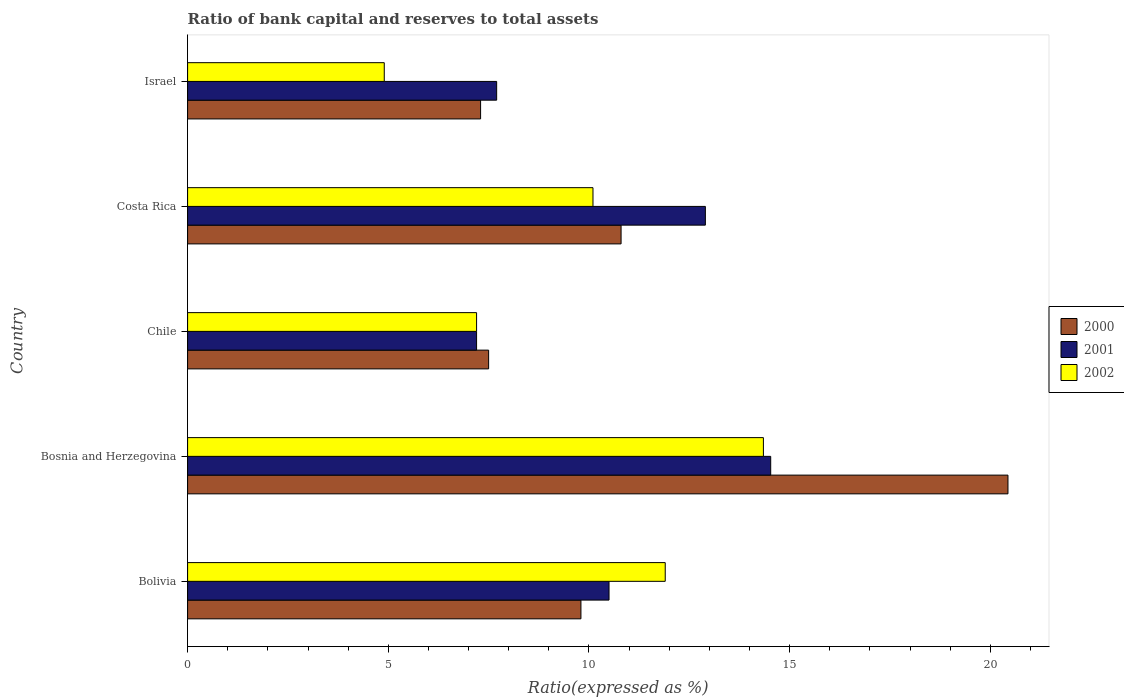How many different coloured bars are there?
Provide a short and direct response. 3. How many groups of bars are there?
Provide a succinct answer. 5. What is the label of the 5th group of bars from the top?
Provide a short and direct response. Bolivia. In how many cases, is the number of bars for a given country not equal to the number of legend labels?
Provide a short and direct response. 0. Across all countries, what is the maximum ratio of bank capital and reserves to total assets in 2000?
Keep it short and to the point. 20.44. Across all countries, what is the minimum ratio of bank capital and reserves to total assets in 2000?
Provide a succinct answer. 7.3. In which country was the ratio of bank capital and reserves to total assets in 2000 maximum?
Keep it short and to the point. Bosnia and Herzegovina. In which country was the ratio of bank capital and reserves to total assets in 2000 minimum?
Your answer should be very brief. Israel. What is the total ratio of bank capital and reserves to total assets in 2001 in the graph?
Your answer should be compact. 52.83. What is the difference between the ratio of bank capital and reserves to total assets in 2001 in Chile and that in Israel?
Give a very brief answer. -0.5. What is the average ratio of bank capital and reserves to total assets in 2001 per country?
Offer a very short reply. 10.57. What is the difference between the ratio of bank capital and reserves to total assets in 2000 and ratio of bank capital and reserves to total assets in 2001 in Israel?
Provide a short and direct response. -0.4. What is the ratio of the ratio of bank capital and reserves to total assets in 2000 in Bosnia and Herzegovina to that in Costa Rica?
Provide a succinct answer. 1.89. Is the ratio of bank capital and reserves to total assets in 2002 in Chile less than that in Costa Rica?
Ensure brevity in your answer.  Yes. What is the difference between the highest and the second highest ratio of bank capital and reserves to total assets in 2001?
Your answer should be very brief. 1.63. What is the difference between the highest and the lowest ratio of bank capital and reserves to total assets in 2002?
Your answer should be compact. 9.45. Is the sum of the ratio of bank capital and reserves to total assets in 2000 in Bosnia and Herzegovina and Chile greater than the maximum ratio of bank capital and reserves to total assets in 2001 across all countries?
Your answer should be compact. Yes. What does the 1st bar from the top in Israel represents?
Your response must be concise. 2002. What does the 3rd bar from the bottom in Israel represents?
Your response must be concise. 2002. How many bars are there?
Ensure brevity in your answer.  15. Are all the bars in the graph horizontal?
Give a very brief answer. Yes. How many countries are there in the graph?
Keep it short and to the point. 5. What is the difference between two consecutive major ticks on the X-axis?
Your answer should be very brief. 5. Are the values on the major ticks of X-axis written in scientific E-notation?
Your response must be concise. No. What is the title of the graph?
Make the answer very short. Ratio of bank capital and reserves to total assets. What is the label or title of the X-axis?
Your answer should be compact. Ratio(expressed as %). What is the label or title of the Y-axis?
Provide a short and direct response. Country. What is the Ratio(expressed as %) of 2000 in Bolivia?
Give a very brief answer. 9.8. What is the Ratio(expressed as %) in 2000 in Bosnia and Herzegovina?
Provide a short and direct response. 20.44. What is the Ratio(expressed as %) in 2001 in Bosnia and Herzegovina?
Keep it short and to the point. 14.53. What is the Ratio(expressed as %) of 2002 in Bosnia and Herzegovina?
Keep it short and to the point. 14.35. What is the Ratio(expressed as %) of 2001 in Chile?
Ensure brevity in your answer.  7.2. What is the Ratio(expressed as %) in 2002 in Chile?
Ensure brevity in your answer.  7.2. What is the Ratio(expressed as %) in 2000 in Costa Rica?
Your response must be concise. 10.8. What is the Ratio(expressed as %) in 2002 in Costa Rica?
Make the answer very short. 10.1. What is the Ratio(expressed as %) in 2002 in Israel?
Ensure brevity in your answer.  4.9. Across all countries, what is the maximum Ratio(expressed as %) in 2000?
Your answer should be compact. 20.44. Across all countries, what is the maximum Ratio(expressed as %) in 2001?
Your response must be concise. 14.53. Across all countries, what is the maximum Ratio(expressed as %) of 2002?
Give a very brief answer. 14.35. Across all countries, what is the minimum Ratio(expressed as %) in 2001?
Provide a short and direct response. 7.2. Across all countries, what is the minimum Ratio(expressed as %) of 2002?
Your answer should be very brief. 4.9. What is the total Ratio(expressed as %) of 2000 in the graph?
Keep it short and to the point. 55.84. What is the total Ratio(expressed as %) in 2001 in the graph?
Your response must be concise. 52.83. What is the total Ratio(expressed as %) of 2002 in the graph?
Offer a terse response. 48.45. What is the difference between the Ratio(expressed as %) in 2000 in Bolivia and that in Bosnia and Herzegovina?
Give a very brief answer. -10.64. What is the difference between the Ratio(expressed as %) of 2001 in Bolivia and that in Bosnia and Herzegovina?
Make the answer very short. -4.03. What is the difference between the Ratio(expressed as %) in 2002 in Bolivia and that in Bosnia and Herzegovina?
Your response must be concise. -2.45. What is the difference between the Ratio(expressed as %) of 2000 in Bolivia and that in Costa Rica?
Provide a short and direct response. -1. What is the difference between the Ratio(expressed as %) of 2002 in Bolivia and that in Israel?
Your answer should be compact. 7. What is the difference between the Ratio(expressed as %) in 2000 in Bosnia and Herzegovina and that in Chile?
Make the answer very short. 12.94. What is the difference between the Ratio(expressed as %) in 2001 in Bosnia and Herzegovina and that in Chile?
Ensure brevity in your answer.  7.33. What is the difference between the Ratio(expressed as %) of 2002 in Bosnia and Herzegovina and that in Chile?
Provide a succinct answer. 7.15. What is the difference between the Ratio(expressed as %) in 2000 in Bosnia and Herzegovina and that in Costa Rica?
Keep it short and to the point. 9.64. What is the difference between the Ratio(expressed as %) of 2001 in Bosnia and Herzegovina and that in Costa Rica?
Give a very brief answer. 1.63. What is the difference between the Ratio(expressed as %) in 2002 in Bosnia and Herzegovina and that in Costa Rica?
Offer a very short reply. 4.25. What is the difference between the Ratio(expressed as %) in 2000 in Bosnia and Herzegovina and that in Israel?
Offer a terse response. 13.14. What is the difference between the Ratio(expressed as %) of 2001 in Bosnia and Herzegovina and that in Israel?
Give a very brief answer. 6.83. What is the difference between the Ratio(expressed as %) in 2002 in Bosnia and Herzegovina and that in Israel?
Make the answer very short. 9.45. What is the difference between the Ratio(expressed as %) in 2001 in Chile and that in Costa Rica?
Your answer should be compact. -5.7. What is the difference between the Ratio(expressed as %) in 2001 in Chile and that in Israel?
Keep it short and to the point. -0.5. What is the difference between the Ratio(expressed as %) in 2002 in Chile and that in Israel?
Provide a succinct answer. 2.3. What is the difference between the Ratio(expressed as %) in 2000 in Costa Rica and that in Israel?
Your answer should be very brief. 3.5. What is the difference between the Ratio(expressed as %) of 2001 in Costa Rica and that in Israel?
Give a very brief answer. 5.2. What is the difference between the Ratio(expressed as %) in 2002 in Costa Rica and that in Israel?
Make the answer very short. 5.2. What is the difference between the Ratio(expressed as %) in 2000 in Bolivia and the Ratio(expressed as %) in 2001 in Bosnia and Herzegovina?
Offer a very short reply. -4.73. What is the difference between the Ratio(expressed as %) in 2000 in Bolivia and the Ratio(expressed as %) in 2002 in Bosnia and Herzegovina?
Make the answer very short. -4.55. What is the difference between the Ratio(expressed as %) of 2001 in Bolivia and the Ratio(expressed as %) of 2002 in Bosnia and Herzegovina?
Your response must be concise. -3.85. What is the difference between the Ratio(expressed as %) in 2000 in Bolivia and the Ratio(expressed as %) in 2001 in Chile?
Offer a very short reply. 2.6. What is the difference between the Ratio(expressed as %) in 2000 in Bolivia and the Ratio(expressed as %) in 2001 in Costa Rica?
Your response must be concise. -3.1. What is the difference between the Ratio(expressed as %) of 2000 in Bolivia and the Ratio(expressed as %) of 2002 in Costa Rica?
Your response must be concise. -0.3. What is the difference between the Ratio(expressed as %) in 2001 in Bolivia and the Ratio(expressed as %) in 2002 in Costa Rica?
Give a very brief answer. 0.4. What is the difference between the Ratio(expressed as %) of 2000 in Bolivia and the Ratio(expressed as %) of 2001 in Israel?
Your response must be concise. 2.1. What is the difference between the Ratio(expressed as %) in 2001 in Bolivia and the Ratio(expressed as %) in 2002 in Israel?
Give a very brief answer. 5.6. What is the difference between the Ratio(expressed as %) in 2000 in Bosnia and Herzegovina and the Ratio(expressed as %) in 2001 in Chile?
Offer a very short reply. 13.24. What is the difference between the Ratio(expressed as %) in 2000 in Bosnia and Herzegovina and the Ratio(expressed as %) in 2002 in Chile?
Provide a short and direct response. 13.24. What is the difference between the Ratio(expressed as %) in 2001 in Bosnia and Herzegovina and the Ratio(expressed as %) in 2002 in Chile?
Your response must be concise. 7.33. What is the difference between the Ratio(expressed as %) of 2000 in Bosnia and Herzegovina and the Ratio(expressed as %) of 2001 in Costa Rica?
Keep it short and to the point. 7.54. What is the difference between the Ratio(expressed as %) in 2000 in Bosnia and Herzegovina and the Ratio(expressed as %) in 2002 in Costa Rica?
Offer a terse response. 10.34. What is the difference between the Ratio(expressed as %) in 2001 in Bosnia and Herzegovina and the Ratio(expressed as %) in 2002 in Costa Rica?
Make the answer very short. 4.43. What is the difference between the Ratio(expressed as %) of 2000 in Bosnia and Herzegovina and the Ratio(expressed as %) of 2001 in Israel?
Give a very brief answer. 12.74. What is the difference between the Ratio(expressed as %) in 2000 in Bosnia and Herzegovina and the Ratio(expressed as %) in 2002 in Israel?
Give a very brief answer. 15.54. What is the difference between the Ratio(expressed as %) of 2001 in Bosnia and Herzegovina and the Ratio(expressed as %) of 2002 in Israel?
Your answer should be compact. 9.63. What is the difference between the Ratio(expressed as %) of 2001 in Chile and the Ratio(expressed as %) of 2002 in Israel?
Ensure brevity in your answer.  2.3. What is the difference between the Ratio(expressed as %) in 2000 in Costa Rica and the Ratio(expressed as %) in 2002 in Israel?
Make the answer very short. 5.9. What is the difference between the Ratio(expressed as %) of 2001 in Costa Rica and the Ratio(expressed as %) of 2002 in Israel?
Provide a succinct answer. 8. What is the average Ratio(expressed as %) of 2000 per country?
Offer a very short reply. 11.17. What is the average Ratio(expressed as %) of 2001 per country?
Your response must be concise. 10.57. What is the average Ratio(expressed as %) of 2002 per country?
Offer a terse response. 9.69. What is the difference between the Ratio(expressed as %) in 2000 and Ratio(expressed as %) in 2001 in Bolivia?
Make the answer very short. -0.7. What is the difference between the Ratio(expressed as %) of 2000 and Ratio(expressed as %) of 2002 in Bolivia?
Your answer should be very brief. -2.1. What is the difference between the Ratio(expressed as %) of 2000 and Ratio(expressed as %) of 2001 in Bosnia and Herzegovina?
Your answer should be very brief. 5.91. What is the difference between the Ratio(expressed as %) in 2000 and Ratio(expressed as %) in 2002 in Bosnia and Herzegovina?
Ensure brevity in your answer.  6.09. What is the difference between the Ratio(expressed as %) of 2001 and Ratio(expressed as %) of 2002 in Bosnia and Herzegovina?
Ensure brevity in your answer.  0.18. What is the difference between the Ratio(expressed as %) of 2001 and Ratio(expressed as %) of 2002 in Chile?
Keep it short and to the point. 0. What is the difference between the Ratio(expressed as %) of 2000 and Ratio(expressed as %) of 2001 in Costa Rica?
Keep it short and to the point. -2.1. What is the difference between the Ratio(expressed as %) of 2000 and Ratio(expressed as %) of 2002 in Costa Rica?
Your response must be concise. 0.7. What is the difference between the Ratio(expressed as %) in 2000 and Ratio(expressed as %) in 2001 in Israel?
Give a very brief answer. -0.4. What is the ratio of the Ratio(expressed as %) of 2000 in Bolivia to that in Bosnia and Herzegovina?
Provide a succinct answer. 0.48. What is the ratio of the Ratio(expressed as %) of 2001 in Bolivia to that in Bosnia and Herzegovina?
Your answer should be very brief. 0.72. What is the ratio of the Ratio(expressed as %) in 2002 in Bolivia to that in Bosnia and Herzegovina?
Make the answer very short. 0.83. What is the ratio of the Ratio(expressed as %) in 2000 in Bolivia to that in Chile?
Provide a short and direct response. 1.31. What is the ratio of the Ratio(expressed as %) in 2001 in Bolivia to that in Chile?
Keep it short and to the point. 1.46. What is the ratio of the Ratio(expressed as %) in 2002 in Bolivia to that in Chile?
Keep it short and to the point. 1.65. What is the ratio of the Ratio(expressed as %) of 2000 in Bolivia to that in Costa Rica?
Give a very brief answer. 0.91. What is the ratio of the Ratio(expressed as %) in 2001 in Bolivia to that in Costa Rica?
Offer a terse response. 0.81. What is the ratio of the Ratio(expressed as %) of 2002 in Bolivia to that in Costa Rica?
Offer a very short reply. 1.18. What is the ratio of the Ratio(expressed as %) in 2000 in Bolivia to that in Israel?
Offer a very short reply. 1.34. What is the ratio of the Ratio(expressed as %) of 2001 in Bolivia to that in Israel?
Provide a short and direct response. 1.36. What is the ratio of the Ratio(expressed as %) in 2002 in Bolivia to that in Israel?
Keep it short and to the point. 2.43. What is the ratio of the Ratio(expressed as %) in 2000 in Bosnia and Herzegovina to that in Chile?
Offer a very short reply. 2.73. What is the ratio of the Ratio(expressed as %) of 2001 in Bosnia and Herzegovina to that in Chile?
Offer a very short reply. 2.02. What is the ratio of the Ratio(expressed as %) of 2002 in Bosnia and Herzegovina to that in Chile?
Your answer should be compact. 1.99. What is the ratio of the Ratio(expressed as %) in 2000 in Bosnia and Herzegovina to that in Costa Rica?
Give a very brief answer. 1.89. What is the ratio of the Ratio(expressed as %) of 2001 in Bosnia and Herzegovina to that in Costa Rica?
Your response must be concise. 1.13. What is the ratio of the Ratio(expressed as %) of 2002 in Bosnia and Herzegovina to that in Costa Rica?
Give a very brief answer. 1.42. What is the ratio of the Ratio(expressed as %) in 2000 in Bosnia and Herzegovina to that in Israel?
Offer a terse response. 2.8. What is the ratio of the Ratio(expressed as %) in 2001 in Bosnia and Herzegovina to that in Israel?
Your answer should be compact. 1.89. What is the ratio of the Ratio(expressed as %) of 2002 in Bosnia and Herzegovina to that in Israel?
Offer a terse response. 2.93. What is the ratio of the Ratio(expressed as %) of 2000 in Chile to that in Costa Rica?
Give a very brief answer. 0.69. What is the ratio of the Ratio(expressed as %) of 2001 in Chile to that in Costa Rica?
Offer a terse response. 0.56. What is the ratio of the Ratio(expressed as %) in 2002 in Chile to that in Costa Rica?
Your response must be concise. 0.71. What is the ratio of the Ratio(expressed as %) in 2000 in Chile to that in Israel?
Offer a terse response. 1.03. What is the ratio of the Ratio(expressed as %) in 2001 in Chile to that in Israel?
Your response must be concise. 0.94. What is the ratio of the Ratio(expressed as %) of 2002 in Chile to that in Israel?
Offer a terse response. 1.47. What is the ratio of the Ratio(expressed as %) in 2000 in Costa Rica to that in Israel?
Make the answer very short. 1.48. What is the ratio of the Ratio(expressed as %) in 2001 in Costa Rica to that in Israel?
Give a very brief answer. 1.68. What is the ratio of the Ratio(expressed as %) of 2002 in Costa Rica to that in Israel?
Keep it short and to the point. 2.06. What is the difference between the highest and the second highest Ratio(expressed as %) in 2000?
Your response must be concise. 9.64. What is the difference between the highest and the second highest Ratio(expressed as %) in 2001?
Your answer should be very brief. 1.63. What is the difference between the highest and the second highest Ratio(expressed as %) of 2002?
Offer a very short reply. 2.45. What is the difference between the highest and the lowest Ratio(expressed as %) in 2000?
Ensure brevity in your answer.  13.14. What is the difference between the highest and the lowest Ratio(expressed as %) in 2001?
Offer a terse response. 7.33. What is the difference between the highest and the lowest Ratio(expressed as %) in 2002?
Give a very brief answer. 9.45. 